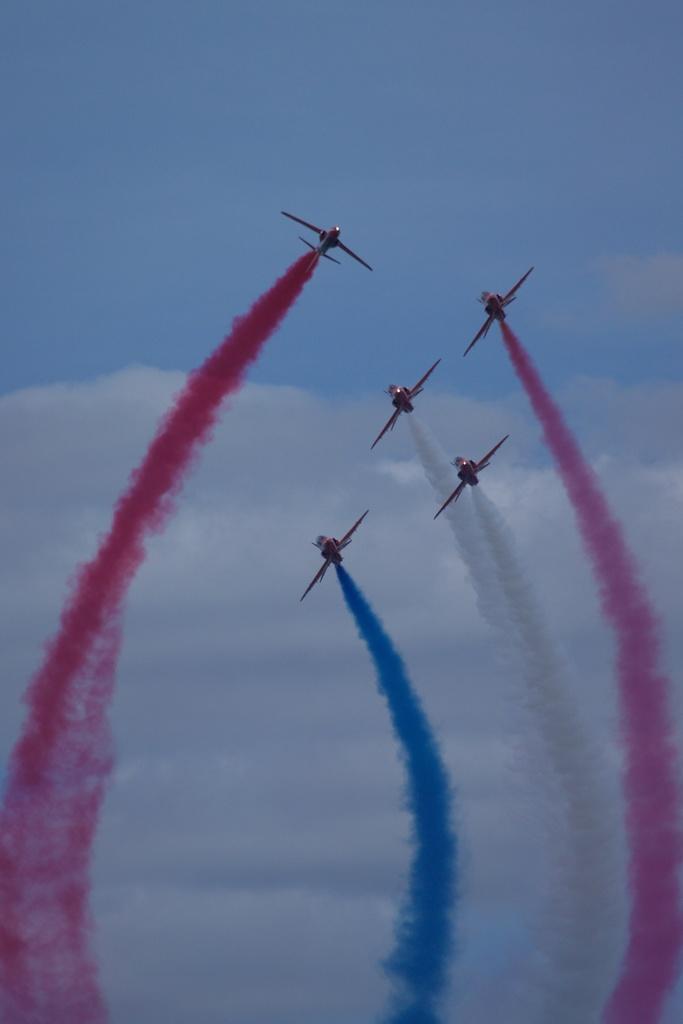Describe this image in one or two sentences. In this image, we can see few aircrafts are in the air. Here we can see smoke. Background there is the cloudy sky. 